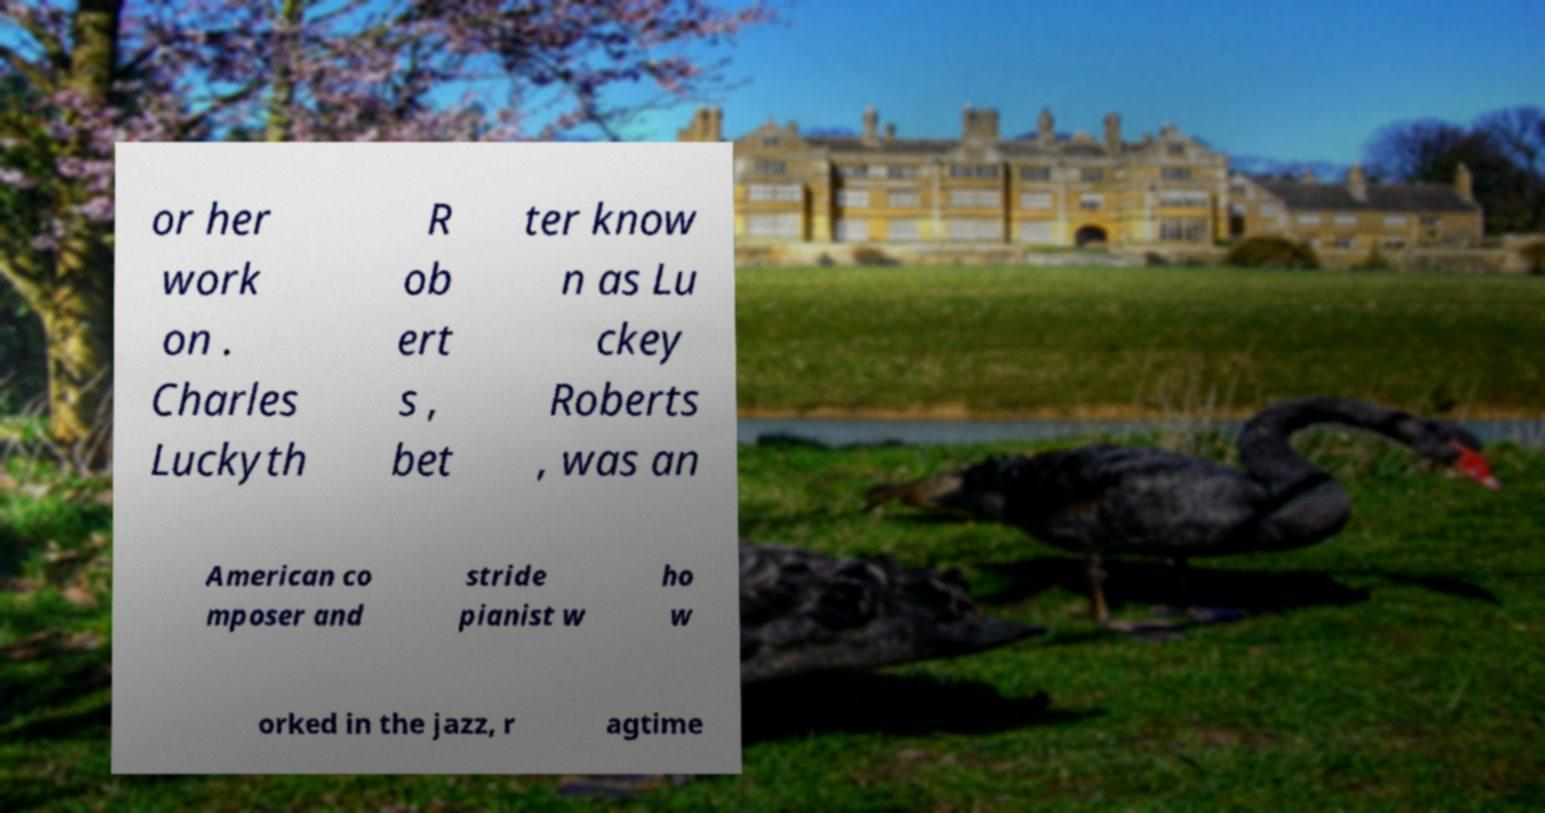Can you accurately transcribe the text from the provided image for me? or her work on . Charles Luckyth R ob ert s , bet ter know n as Lu ckey Roberts , was an American co mposer and stride pianist w ho w orked in the jazz, r agtime 